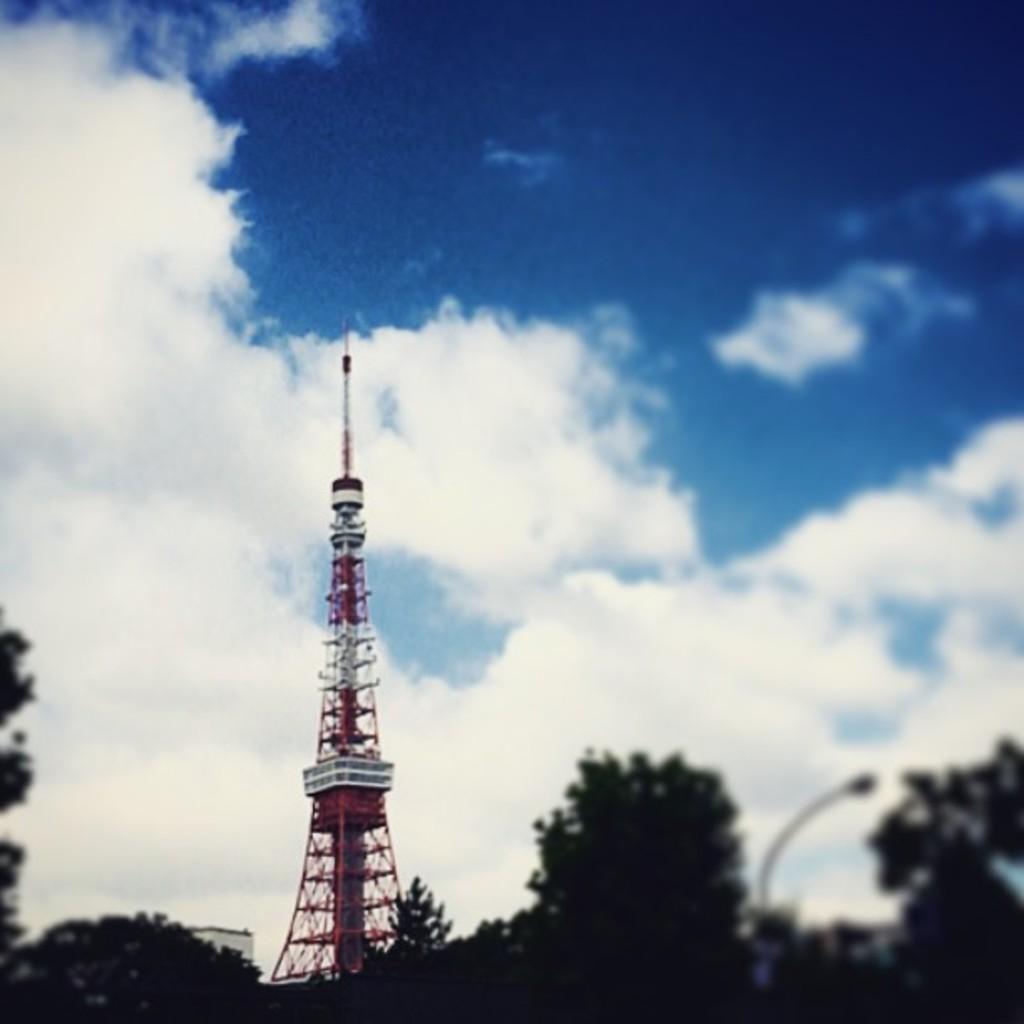In one or two sentences, can you explain what this image depicts? In this image we can see the tower and in the background, we can see the sky and cloud. 